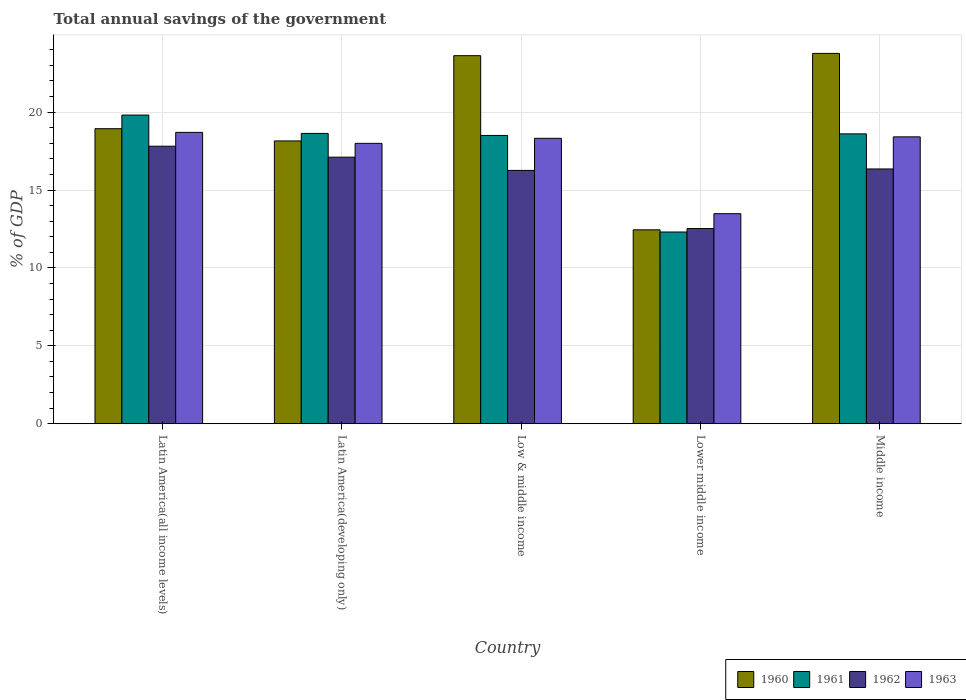How many groups of bars are there?
Provide a succinct answer. 5. Are the number of bars per tick equal to the number of legend labels?
Give a very brief answer. Yes. How many bars are there on the 2nd tick from the right?
Offer a terse response. 4. What is the label of the 2nd group of bars from the left?
Make the answer very short. Latin America(developing only). What is the total annual savings of the government in 1963 in Low & middle income?
Offer a terse response. 18.32. Across all countries, what is the maximum total annual savings of the government in 1962?
Keep it short and to the point. 17.81. Across all countries, what is the minimum total annual savings of the government in 1962?
Keep it short and to the point. 12.53. In which country was the total annual savings of the government in 1963 maximum?
Offer a terse response. Latin America(all income levels). In which country was the total annual savings of the government in 1961 minimum?
Give a very brief answer. Lower middle income. What is the total total annual savings of the government in 1961 in the graph?
Ensure brevity in your answer.  87.85. What is the difference between the total annual savings of the government in 1962 in Latin America(all income levels) and that in Lower middle income?
Give a very brief answer. 5.28. What is the difference between the total annual savings of the government in 1961 in Latin America(all income levels) and the total annual savings of the government in 1960 in Low & middle income?
Offer a terse response. -3.81. What is the average total annual savings of the government in 1960 per country?
Make the answer very short. 19.38. What is the difference between the total annual savings of the government of/in 1963 and total annual savings of the government of/in 1961 in Middle income?
Ensure brevity in your answer.  -0.19. In how many countries, is the total annual savings of the government in 1961 greater than 9 %?
Your answer should be compact. 5. What is the ratio of the total annual savings of the government in 1963 in Latin America(all income levels) to that in Middle income?
Your response must be concise. 1.02. What is the difference between the highest and the second highest total annual savings of the government in 1960?
Your answer should be very brief. -4.69. What is the difference between the highest and the lowest total annual savings of the government in 1961?
Make the answer very short. 7.5. What does the 1st bar from the right in Middle income represents?
Your answer should be very brief. 1963. Are all the bars in the graph horizontal?
Provide a short and direct response. No. How many countries are there in the graph?
Provide a short and direct response. 5. What is the difference between two consecutive major ticks on the Y-axis?
Keep it short and to the point. 5. Does the graph contain any zero values?
Provide a succinct answer. No. Does the graph contain grids?
Offer a terse response. Yes. Where does the legend appear in the graph?
Offer a terse response. Bottom right. How are the legend labels stacked?
Offer a very short reply. Horizontal. What is the title of the graph?
Offer a terse response. Total annual savings of the government. What is the label or title of the X-axis?
Offer a very short reply. Country. What is the label or title of the Y-axis?
Ensure brevity in your answer.  % of GDP. What is the % of GDP in 1960 in Latin America(all income levels)?
Your response must be concise. 18.93. What is the % of GDP of 1961 in Latin America(all income levels)?
Offer a very short reply. 19.81. What is the % of GDP in 1962 in Latin America(all income levels)?
Provide a short and direct response. 17.81. What is the % of GDP of 1963 in Latin America(all income levels)?
Your answer should be compact. 18.7. What is the % of GDP of 1960 in Latin America(developing only)?
Ensure brevity in your answer.  18.15. What is the % of GDP in 1961 in Latin America(developing only)?
Your answer should be compact. 18.63. What is the % of GDP in 1962 in Latin America(developing only)?
Your answer should be very brief. 17.11. What is the % of GDP in 1963 in Latin America(developing only)?
Give a very brief answer. 17.99. What is the % of GDP in 1960 in Low & middle income?
Your response must be concise. 23.62. What is the % of GDP in 1961 in Low & middle income?
Ensure brevity in your answer.  18.5. What is the % of GDP of 1962 in Low & middle income?
Provide a short and direct response. 16.26. What is the % of GDP in 1963 in Low & middle income?
Make the answer very short. 18.32. What is the % of GDP in 1960 in Lower middle income?
Offer a terse response. 12.45. What is the % of GDP in 1961 in Lower middle income?
Your response must be concise. 12.3. What is the % of GDP of 1962 in Lower middle income?
Your answer should be compact. 12.53. What is the % of GDP in 1963 in Lower middle income?
Keep it short and to the point. 13.48. What is the % of GDP in 1960 in Middle income?
Ensure brevity in your answer.  23.77. What is the % of GDP of 1961 in Middle income?
Offer a very short reply. 18.6. What is the % of GDP of 1962 in Middle income?
Ensure brevity in your answer.  16.35. What is the % of GDP in 1963 in Middle income?
Keep it short and to the point. 18.41. Across all countries, what is the maximum % of GDP in 1960?
Your answer should be compact. 23.77. Across all countries, what is the maximum % of GDP of 1961?
Ensure brevity in your answer.  19.81. Across all countries, what is the maximum % of GDP in 1962?
Your answer should be compact. 17.81. Across all countries, what is the maximum % of GDP in 1963?
Give a very brief answer. 18.7. Across all countries, what is the minimum % of GDP of 1960?
Offer a very short reply. 12.45. Across all countries, what is the minimum % of GDP of 1961?
Provide a short and direct response. 12.3. Across all countries, what is the minimum % of GDP in 1962?
Your answer should be compact. 12.53. Across all countries, what is the minimum % of GDP of 1963?
Provide a succinct answer. 13.48. What is the total % of GDP in 1960 in the graph?
Provide a succinct answer. 96.92. What is the total % of GDP of 1961 in the graph?
Make the answer very short. 87.85. What is the total % of GDP in 1962 in the graph?
Provide a short and direct response. 80.06. What is the total % of GDP in 1963 in the graph?
Offer a very short reply. 86.91. What is the difference between the % of GDP of 1960 in Latin America(all income levels) and that in Latin America(developing only)?
Your answer should be compact. 0.78. What is the difference between the % of GDP in 1961 in Latin America(all income levels) and that in Latin America(developing only)?
Your response must be concise. 1.18. What is the difference between the % of GDP in 1962 in Latin America(all income levels) and that in Latin America(developing only)?
Offer a very short reply. 0.7. What is the difference between the % of GDP of 1963 in Latin America(all income levels) and that in Latin America(developing only)?
Provide a short and direct response. 0.7. What is the difference between the % of GDP of 1960 in Latin America(all income levels) and that in Low & middle income?
Make the answer very short. -4.69. What is the difference between the % of GDP of 1961 in Latin America(all income levels) and that in Low & middle income?
Your answer should be very brief. 1.31. What is the difference between the % of GDP in 1962 in Latin America(all income levels) and that in Low & middle income?
Ensure brevity in your answer.  1.55. What is the difference between the % of GDP of 1963 in Latin America(all income levels) and that in Low & middle income?
Ensure brevity in your answer.  0.38. What is the difference between the % of GDP in 1960 in Latin America(all income levels) and that in Lower middle income?
Ensure brevity in your answer.  6.49. What is the difference between the % of GDP in 1961 in Latin America(all income levels) and that in Lower middle income?
Your response must be concise. 7.5. What is the difference between the % of GDP of 1962 in Latin America(all income levels) and that in Lower middle income?
Make the answer very short. 5.28. What is the difference between the % of GDP in 1963 in Latin America(all income levels) and that in Lower middle income?
Keep it short and to the point. 5.22. What is the difference between the % of GDP of 1960 in Latin America(all income levels) and that in Middle income?
Make the answer very short. -4.83. What is the difference between the % of GDP in 1961 in Latin America(all income levels) and that in Middle income?
Give a very brief answer. 1.21. What is the difference between the % of GDP of 1962 in Latin America(all income levels) and that in Middle income?
Offer a terse response. 1.46. What is the difference between the % of GDP in 1963 in Latin America(all income levels) and that in Middle income?
Ensure brevity in your answer.  0.29. What is the difference between the % of GDP in 1960 in Latin America(developing only) and that in Low & middle income?
Make the answer very short. -5.47. What is the difference between the % of GDP of 1961 in Latin America(developing only) and that in Low & middle income?
Your response must be concise. 0.13. What is the difference between the % of GDP of 1962 in Latin America(developing only) and that in Low & middle income?
Your response must be concise. 0.85. What is the difference between the % of GDP in 1963 in Latin America(developing only) and that in Low & middle income?
Offer a very short reply. -0.32. What is the difference between the % of GDP in 1960 in Latin America(developing only) and that in Lower middle income?
Offer a very short reply. 5.7. What is the difference between the % of GDP in 1961 in Latin America(developing only) and that in Lower middle income?
Ensure brevity in your answer.  6.33. What is the difference between the % of GDP of 1962 in Latin America(developing only) and that in Lower middle income?
Ensure brevity in your answer.  4.58. What is the difference between the % of GDP in 1963 in Latin America(developing only) and that in Lower middle income?
Keep it short and to the point. 4.51. What is the difference between the % of GDP of 1960 in Latin America(developing only) and that in Middle income?
Offer a very short reply. -5.62. What is the difference between the % of GDP in 1961 in Latin America(developing only) and that in Middle income?
Make the answer very short. 0.03. What is the difference between the % of GDP in 1962 in Latin America(developing only) and that in Middle income?
Offer a very short reply. 0.76. What is the difference between the % of GDP in 1963 in Latin America(developing only) and that in Middle income?
Your response must be concise. -0.42. What is the difference between the % of GDP of 1960 in Low & middle income and that in Lower middle income?
Offer a terse response. 11.18. What is the difference between the % of GDP of 1961 in Low & middle income and that in Lower middle income?
Your answer should be very brief. 6.2. What is the difference between the % of GDP in 1962 in Low & middle income and that in Lower middle income?
Your answer should be very brief. 3.73. What is the difference between the % of GDP of 1963 in Low & middle income and that in Lower middle income?
Keep it short and to the point. 4.84. What is the difference between the % of GDP in 1960 in Low & middle income and that in Middle income?
Give a very brief answer. -0.15. What is the difference between the % of GDP of 1961 in Low & middle income and that in Middle income?
Your answer should be very brief. -0.1. What is the difference between the % of GDP of 1962 in Low & middle income and that in Middle income?
Give a very brief answer. -0.09. What is the difference between the % of GDP of 1963 in Low & middle income and that in Middle income?
Give a very brief answer. -0.09. What is the difference between the % of GDP of 1960 in Lower middle income and that in Middle income?
Your answer should be compact. -11.32. What is the difference between the % of GDP of 1961 in Lower middle income and that in Middle income?
Your answer should be compact. -6.3. What is the difference between the % of GDP in 1962 in Lower middle income and that in Middle income?
Offer a very short reply. -3.82. What is the difference between the % of GDP in 1963 in Lower middle income and that in Middle income?
Provide a succinct answer. -4.93. What is the difference between the % of GDP in 1960 in Latin America(all income levels) and the % of GDP in 1961 in Latin America(developing only)?
Your response must be concise. 0.3. What is the difference between the % of GDP of 1960 in Latin America(all income levels) and the % of GDP of 1962 in Latin America(developing only)?
Your response must be concise. 1.83. What is the difference between the % of GDP of 1960 in Latin America(all income levels) and the % of GDP of 1963 in Latin America(developing only)?
Offer a terse response. 0.94. What is the difference between the % of GDP in 1961 in Latin America(all income levels) and the % of GDP in 1962 in Latin America(developing only)?
Keep it short and to the point. 2.7. What is the difference between the % of GDP of 1961 in Latin America(all income levels) and the % of GDP of 1963 in Latin America(developing only)?
Offer a very short reply. 1.81. What is the difference between the % of GDP in 1962 in Latin America(all income levels) and the % of GDP in 1963 in Latin America(developing only)?
Provide a succinct answer. -0.18. What is the difference between the % of GDP of 1960 in Latin America(all income levels) and the % of GDP of 1961 in Low & middle income?
Your answer should be compact. 0.43. What is the difference between the % of GDP in 1960 in Latin America(all income levels) and the % of GDP in 1962 in Low & middle income?
Ensure brevity in your answer.  2.68. What is the difference between the % of GDP in 1960 in Latin America(all income levels) and the % of GDP in 1963 in Low & middle income?
Provide a succinct answer. 0.62. What is the difference between the % of GDP of 1961 in Latin America(all income levels) and the % of GDP of 1962 in Low & middle income?
Provide a short and direct response. 3.55. What is the difference between the % of GDP in 1961 in Latin America(all income levels) and the % of GDP in 1963 in Low & middle income?
Your response must be concise. 1.49. What is the difference between the % of GDP in 1962 in Latin America(all income levels) and the % of GDP in 1963 in Low & middle income?
Provide a succinct answer. -0.51. What is the difference between the % of GDP of 1960 in Latin America(all income levels) and the % of GDP of 1961 in Lower middle income?
Give a very brief answer. 6.63. What is the difference between the % of GDP of 1960 in Latin America(all income levels) and the % of GDP of 1962 in Lower middle income?
Your response must be concise. 6.41. What is the difference between the % of GDP in 1960 in Latin America(all income levels) and the % of GDP in 1963 in Lower middle income?
Offer a very short reply. 5.45. What is the difference between the % of GDP in 1961 in Latin America(all income levels) and the % of GDP in 1962 in Lower middle income?
Provide a succinct answer. 7.28. What is the difference between the % of GDP in 1961 in Latin America(all income levels) and the % of GDP in 1963 in Lower middle income?
Provide a short and direct response. 6.33. What is the difference between the % of GDP in 1962 in Latin America(all income levels) and the % of GDP in 1963 in Lower middle income?
Make the answer very short. 4.33. What is the difference between the % of GDP of 1960 in Latin America(all income levels) and the % of GDP of 1961 in Middle income?
Provide a short and direct response. 0.33. What is the difference between the % of GDP of 1960 in Latin America(all income levels) and the % of GDP of 1962 in Middle income?
Offer a very short reply. 2.58. What is the difference between the % of GDP in 1960 in Latin America(all income levels) and the % of GDP in 1963 in Middle income?
Offer a terse response. 0.52. What is the difference between the % of GDP in 1961 in Latin America(all income levels) and the % of GDP in 1962 in Middle income?
Keep it short and to the point. 3.46. What is the difference between the % of GDP of 1961 in Latin America(all income levels) and the % of GDP of 1963 in Middle income?
Your answer should be compact. 1.4. What is the difference between the % of GDP in 1962 in Latin America(all income levels) and the % of GDP in 1963 in Middle income?
Offer a very short reply. -0.6. What is the difference between the % of GDP in 1960 in Latin America(developing only) and the % of GDP in 1961 in Low & middle income?
Offer a very short reply. -0.35. What is the difference between the % of GDP in 1960 in Latin America(developing only) and the % of GDP in 1962 in Low & middle income?
Offer a terse response. 1.89. What is the difference between the % of GDP in 1960 in Latin America(developing only) and the % of GDP in 1963 in Low & middle income?
Give a very brief answer. -0.17. What is the difference between the % of GDP in 1961 in Latin America(developing only) and the % of GDP in 1962 in Low & middle income?
Offer a very short reply. 2.37. What is the difference between the % of GDP of 1961 in Latin America(developing only) and the % of GDP of 1963 in Low & middle income?
Your answer should be very brief. 0.31. What is the difference between the % of GDP in 1962 in Latin America(developing only) and the % of GDP in 1963 in Low & middle income?
Give a very brief answer. -1.21. What is the difference between the % of GDP of 1960 in Latin America(developing only) and the % of GDP of 1961 in Lower middle income?
Your response must be concise. 5.85. What is the difference between the % of GDP in 1960 in Latin America(developing only) and the % of GDP in 1962 in Lower middle income?
Keep it short and to the point. 5.62. What is the difference between the % of GDP in 1960 in Latin America(developing only) and the % of GDP in 1963 in Lower middle income?
Keep it short and to the point. 4.67. What is the difference between the % of GDP in 1961 in Latin America(developing only) and the % of GDP in 1962 in Lower middle income?
Provide a succinct answer. 6.11. What is the difference between the % of GDP of 1961 in Latin America(developing only) and the % of GDP of 1963 in Lower middle income?
Provide a short and direct response. 5.15. What is the difference between the % of GDP of 1962 in Latin America(developing only) and the % of GDP of 1963 in Lower middle income?
Provide a short and direct response. 3.63. What is the difference between the % of GDP of 1960 in Latin America(developing only) and the % of GDP of 1961 in Middle income?
Provide a succinct answer. -0.45. What is the difference between the % of GDP of 1960 in Latin America(developing only) and the % of GDP of 1962 in Middle income?
Keep it short and to the point. 1.8. What is the difference between the % of GDP of 1960 in Latin America(developing only) and the % of GDP of 1963 in Middle income?
Offer a terse response. -0.26. What is the difference between the % of GDP in 1961 in Latin America(developing only) and the % of GDP in 1962 in Middle income?
Your answer should be compact. 2.28. What is the difference between the % of GDP of 1961 in Latin America(developing only) and the % of GDP of 1963 in Middle income?
Your answer should be very brief. 0.22. What is the difference between the % of GDP of 1962 in Latin America(developing only) and the % of GDP of 1963 in Middle income?
Give a very brief answer. -1.3. What is the difference between the % of GDP in 1960 in Low & middle income and the % of GDP in 1961 in Lower middle income?
Ensure brevity in your answer.  11.32. What is the difference between the % of GDP in 1960 in Low & middle income and the % of GDP in 1962 in Lower middle income?
Your answer should be very brief. 11.09. What is the difference between the % of GDP in 1960 in Low & middle income and the % of GDP in 1963 in Lower middle income?
Offer a very short reply. 10.14. What is the difference between the % of GDP in 1961 in Low & middle income and the % of GDP in 1962 in Lower middle income?
Your answer should be compact. 5.97. What is the difference between the % of GDP of 1961 in Low & middle income and the % of GDP of 1963 in Lower middle income?
Provide a short and direct response. 5.02. What is the difference between the % of GDP of 1962 in Low & middle income and the % of GDP of 1963 in Lower middle income?
Provide a succinct answer. 2.78. What is the difference between the % of GDP in 1960 in Low & middle income and the % of GDP in 1961 in Middle income?
Provide a succinct answer. 5.02. What is the difference between the % of GDP in 1960 in Low & middle income and the % of GDP in 1962 in Middle income?
Ensure brevity in your answer.  7.27. What is the difference between the % of GDP in 1960 in Low & middle income and the % of GDP in 1963 in Middle income?
Provide a succinct answer. 5.21. What is the difference between the % of GDP in 1961 in Low & middle income and the % of GDP in 1962 in Middle income?
Provide a succinct answer. 2.15. What is the difference between the % of GDP in 1961 in Low & middle income and the % of GDP in 1963 in Middle income?
Offer a very short reply. 0.09. What is the difference between the % of GDP in 1962 in Low & middle income and the % of GDP in 1963 in Middle income?
Your answer should be very brief. -2.15. What is the difference between the % of GDP in 1960 in Lower middle income and the % of GDP in 1961 in Middle income?
Ensure brevity in your answer.  -6.16. What is the difference between the % of GDP of 1960 in Lower middle income and the % of GDP of 1962 in Middle income?
Keep it short and to the point. -3.9. What is the difference between the % of GDP of 1960 in Lower middle income and the % of GDP of 1963 in Middle income?
Provide a succinct answer. -5.97. What is the difference between the % of GDP in 1961 in Lower middle income and the % of GDP in 1962 in Middle income?
Make the answer very short. -4.05. What is the difference between the % of GDP of 1961 in Lower middle income and the % of GDP of 1963 in Middle income?
Your response must be concise. -6.11. What is the difference between the % of GDP in 1962 in Lower middle income and the % of GDP in 1963 in Middle income?
Offer a very short reply. -5.88. What is the average % of GDP in 1960 per country?
Keep it short and to the point. 19.38. What is the average % of GDP in 1961 per country?
Offer a very short reply. 17.57. What is the average % of GDP in 1962 per country?
Provide a short and direct response. 16.01. What is the average % of GDP of 1963 per country?
Make the answer very short. 17.38. What is the difference between the % of GDP in 1960 and % of GDP in 1961 in Latin America(all income levels)?
Offer a very short reply. -0.87. What is the difference between the % of GDP in 1960 and % of GDP in 1962 in Latin America(all income levels)?
Provide a short and direct response. 1.12. What is the difference between the % of GDP of 1960 and % of GDP of 1963 in Latin America(all income levels)?
Offer a terse response. 0.24. What is the difference between the % of GDP of 1961 and % of GDP of 1962 in Latin America(all income levels)?
Provide a succinct answer. 2. What is the difference between the % of GDP of 1961 and % of GDP of 1963 in Latin America(all income levels)?
Provide a succinct answer. 1.11. What is the difference between the % of GDP of 1962 and % of GDP of 1963 in Latin America(all income levels)?
Provide a short and direct response. -0.89. What is the difference between the % of GDP in 1960 and % of GDP in 1961 in Latin America(developing only)?
Offer a very short reply. -0.48. What is the difference between the % of GDP in 1960 and % of GDP in 1962 in Latin America(developing only)?
Give a very brief answer. 1.04. What is the difference between the % of GDP of 1960 and % of GDP of 1963 in Latin America(developing only)?
Your answer should be very brief. 0.16. What is the difference between the % of GDP in 1961 and % of GDP in 1962 in Latin America(developing only)?
Your answer should be very brief. 1.52. What is the difference between the % of GDP in 1961 and % of GDP in 1963 in Latin America(developing only)?
Offer a very short reply. 0.64. What is the difference between the % of GDP in 1962 and % of GDP in 1963 in Latin America(developing only)?
Your answer should be very brief. -0.89. What is the difference between the % of GDP in 1960 and % of GDP in 1961 in Low & middle income?
Keep it short and to the point. 5.12. What is the difference between the % of GDP of 1960 and % of GDP of 1962 in Low & middle income?
Offer a terse response. 7.36. What is the difference between the % of GDP of 1960 and % of GDP of 1963 in Low & middle income?
Give a very brief answer. 5.3. What is the difference between the % of GDP in 1961 and % of GDP in 1962 in Low & middle income?
Offer a very short reply. 2.24. What is the difference between the % of GDP of 1961 and % of GDP of 1963 in Low & middle income?
Give a very brief answer. 0.18. What is the difference between the % of GDP in 1962 and % of GDP in 1963 in Low & middle income?
Offer a terse response. -2.06. What is the difference between the % of GDP in 1960 and % of GDP in 1961 in Lower middle income?
Offer a terse response. 0.14. What is the difference between the % of GDP of 1960 and % of GDP of 1962 in Lower middle income?
Provide a succinct answer. -0.08. What is the difference between the % of GDP of 1960 and % of GDP of 1963 in Lower middle income?
Your answer should be very brief. -1.04. What is the difference between the % of GDP of 1961 and % of GDP of 1962 in Lower middle income?
Keep it short and to the point. -0.22. What is the difference between the % of GDP in 1961 and % of GDP in 1963 in Lower middle income?
Your answer should be compact. -1.18. What is the difference between the % of GDP of 1962 and % of GDP of 1963 in Lower middle income?
Offer a terse response. -0.95. What is the difference between the % of GDP of 1960 and % of GDP of 1961 in Middle income?
Make the answer very short. 5.17. What is the difference between the % of GDP in 1960 and % of GDP in 1962 in Middle income?
Your response must be concise. 7.42. What is the difference between the % of GDP of 1960 and % of GDP of 1963 in Middle income?
Provide a short and direct response. 5.36. What is the difference between the % of GDP in 1961 and % of GDP in 1962 in Middle income?
Ensure brevity in your answer.  2.25. What is the difference between the % of GDP in 1961 and % of GDP in 1963 in Middle income?
Offer a terse response. 0.19. What is the difference between the % of GDP in 1962 and % of GDP in 1963 in Middle income?
Keep it short and to the point. -2.06. What is the ratio of the % of GDP of 1960 in Latin America(all income levels) to that in Latin America(developing only)?
Give a very brief answer. 1.04. What is the ratio of the % of GDP in 1961 in Latin America(all income levels) to that in Latin America(developing only)?
Give a very brief answer. 1.06. What is the ratio of the % of GDP of 1962 in Latin America(all income levels) to that in Latin America(developing only)?
Offer a very short reply. 1.04. What is the ratio of the % of GDP in 1963 in Latin America(all income levels) to that in Latin America(developing only)?
Your response must be concise. 1.04. What is the ratio of the % of GDP in 1960 in Latin America(all income levels) to that in Low & middle income?
Make the answer very short. 0.8. What is the ratio of the % of GDP in 1961 in Latin America(all income levels) to that in Low & middle income?
Make the answer very short. 1.07. What is the ratio of the % of GDP of 1962 in Latin America(all income levels) to that in Low & middle income?
Make the answer very short. 1.1. What is the ratio of the % of GDP of 1963 in Latin America(all income levels) to that in Low & middle income?
Offer a terse response. 1.02. What is the ratio of the % of GDP of 1960 in Latin America(all income levels) to that in Lower middle income?
Keep it short and to the point. 1.52. What is the ratio of the % of GDP of 1961 in Latin America(all income levels) to that in Lower middle income?
Make the answer very short. 1.61. What is the ratio of the % of GDP in 1962 in Latin America(all income levels) to that in Lower middle income?
Make the answer very short. 1.42. What is the ratio of the % of GDP in 1963 in Latin America(all income levels) to that in Lower middle income?
Make the answer very short. 1.39. What is the ratio of the % of GDP in 1960 in Latin America(all income levels) to that in Middle income?
Your response must be concise. 0.8. What is the ratio of the % of GDP of 1961 in Latin America(all income levels) to that in Middle income?
Offer a very short reply. 1.06. What is the ratio of the % of GDP of 1962 in Latin America(all income levels) to that in Middle income?
Your answer should be very brief. 1.09. What is the ratio of the % of GDP in 1963 in Latin America(all income levels) to that in Middle income?
Your answer should be compact. 1.02. What is the ratio of the % of GDP in 1960 in Latin America(developing only) to that in Low & middle income?
Keep it short and to the point. 0.77. What is the ratio of the % of GDP of 1961 in Latin America(developing only) to that in Low & middle income?
Your answer should be compact. 1.01. What is the ratio of the % of GDP of 1962 in Latin America(developing only) to that in Low & middle income?
Provide a short and direct response. 1.05. What is the ratio of the % of GDP of 1963 in Latin America(developing only) to that in Low & middle income?
Offer a very short reply. 0.98. What is the ratio of the % of GDP of 1960 in Latin America(developing only) to that in Lower middle income?
Give a very brief answer. 1.46. What is the ratio of the % of GDP in 1961 in Latin America(developing only) to that in Lower middle income?
Keep it short and to the point. 1.51. What is the ratio of the % of GDP in 1962 in Latin America(developing only) to that in Lower middle income?
Offer a very short reply. 1.37. What is the ratio of the % of GDP of 1963 in Latin America(developing only) to that in Lower middle income?
Ensure brevity in your answer.  1.33. What is the ratio of the % of GDP in 1960 in Latin America(developing only) to that in Middle income?
Offer a terse response. 0.76. What is the ratio of the % of GDP of 1961 in Latin America(developing only) to that in Middle income?
Offer a very short reply. 1. What is the ratio of the % of GDP in 1962 in Latin America(developing only) to that in Middle income?
Make the answer very short. 1.05. What is the ratio of the % of GDP in 1963 in Latin America(developing only) to that in Middle income?
Your answer should be very brief. 0.98. What is the ratio of the % of GDP in 1960 in Low & middle income to that in Lower middle income?
Provide a short and direct response. 1.9. What is the ratio of the % of GDP in 1961 in Low & middle income to that in Lower middle income?
Your answer should be compact. 1.5. What is the ratio of the % of GDP of 1962 in Low & middle income to that in Lower middle income?
Give a very brief answer. 1.3. What is the ratio of the % of GDP in 1963 in Low & middle income to that in Lower middle income?
Make the answer very short. 1.36. What is the ratio of the % of GDP of 1962 in Low & middle income to that in Middle income?
Provide a succinct answer. 0.99. What is the ratio of the % of GDP in 1963 in Low & middle income to that in Middle income?
Keep it short and to the point. 0.99. What is the ratio of the % of GDP in 1960 in Lower middle income to that in Middle income?
Provide a succinct answer. 0.52. What is the ratio of the % of GDP of 1961 in Lower middle income to that in Middle income?
Provide a succinct answer. 0.66. What is the ratio of the % of GDP of 1962 in Lower middle income to that in Middle income?
Your answer should be compact. 0.77. What is the ratio of the % of GDP in 1963 in Lower middle income to that in Middle income?
Ensure brevity in your answer.  0.73. What is the difference between the highest and the second highest % of GDP in 1960?
Offer a terse response. 0.15. What is the difference between the highest and the second highest % of GDP in 1961?
Keep it short and to the point. 1.18. What is the difference between the highest and the second highest % of GDP of 1962?
Keep it short and to the point. 0.7. What is the difference between the highest and the second highest % of GDP in 1963?
Offer a very short reply. 0.29. What is the difference between the highest and the lowest % of GDP in 1960?
Give a very brief answer. 11.32. What is the difference between the highest and the lowest % of GDP of 1961?
Keep it short and to the point. 7.5. What is the difference between the highest and the lowest % of GDP of 1962?
Your response must be concise. 5.28. What is the difference between the highest and the lowest % of GDP of 1963?
Ensure brevity in your answer.  5.22. 